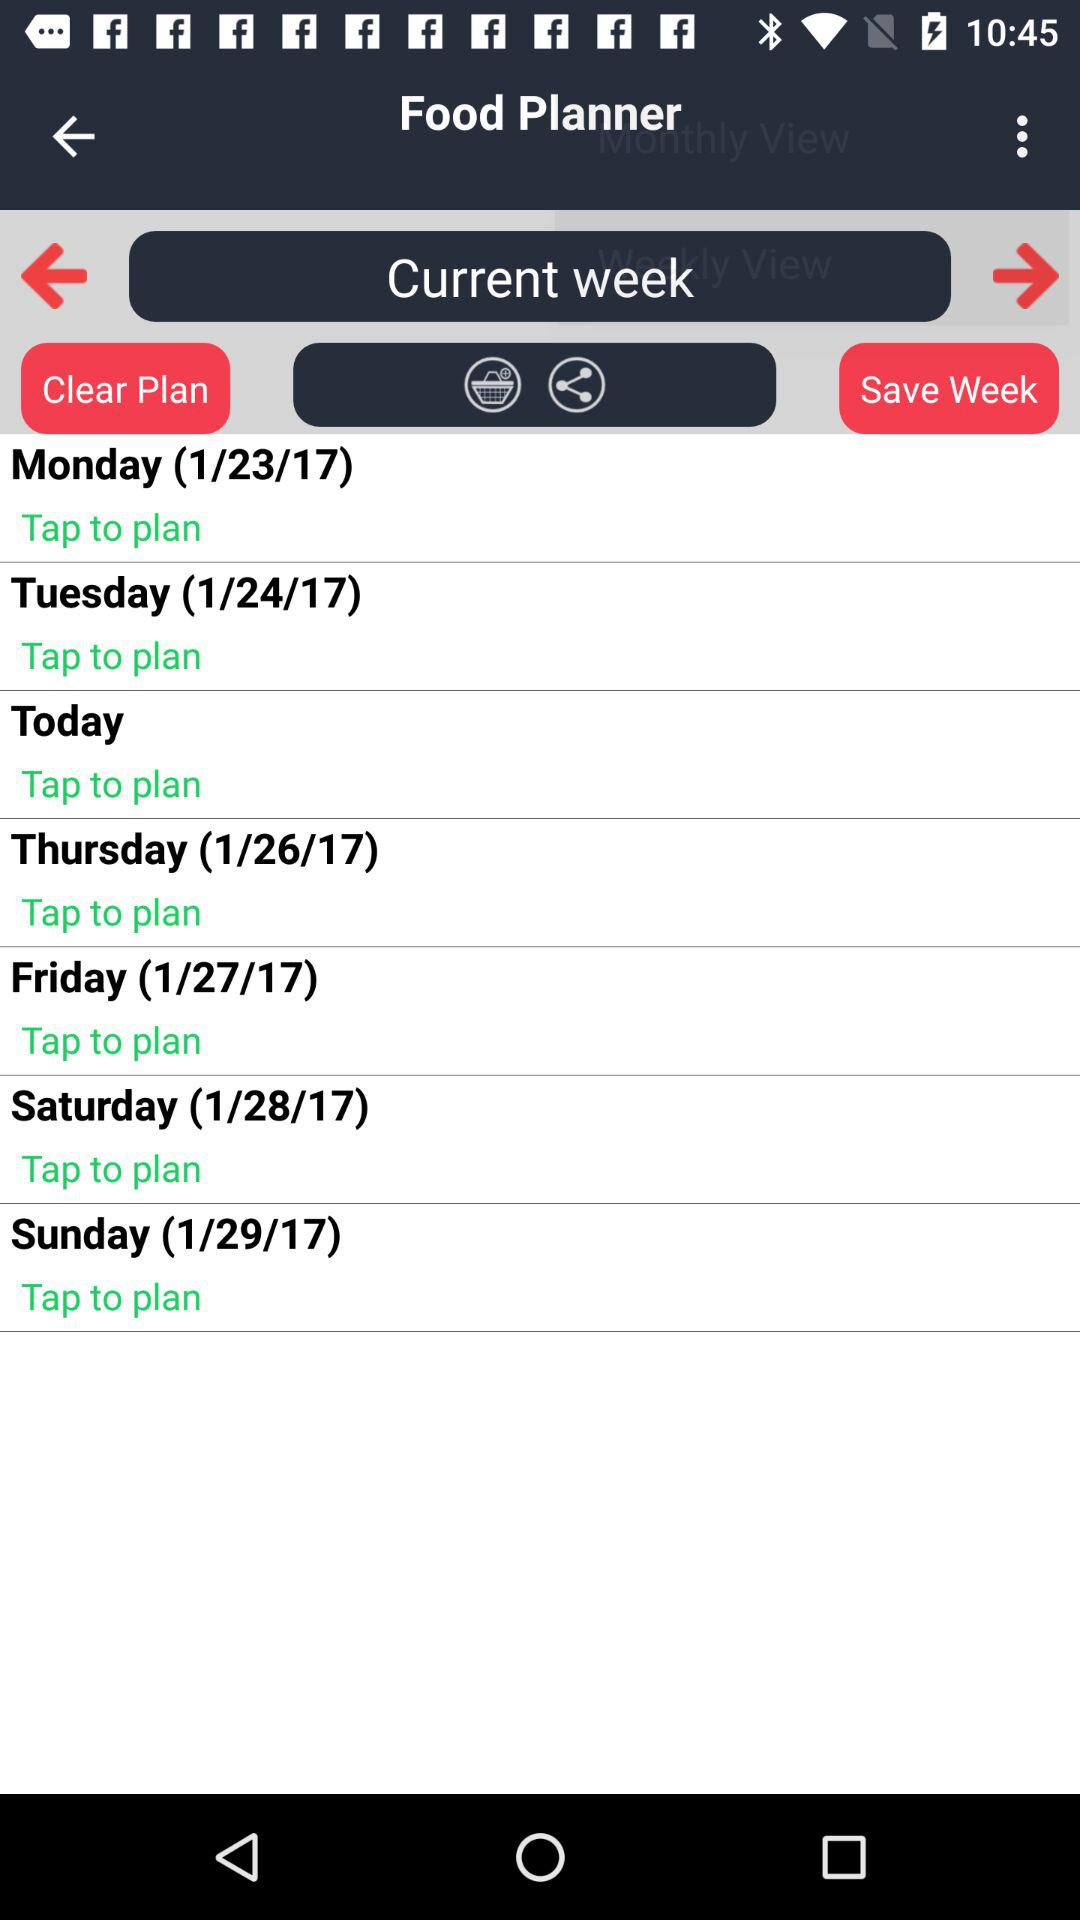Which date will Sunday fall on? Sunday will fall on January 29, 2017. 